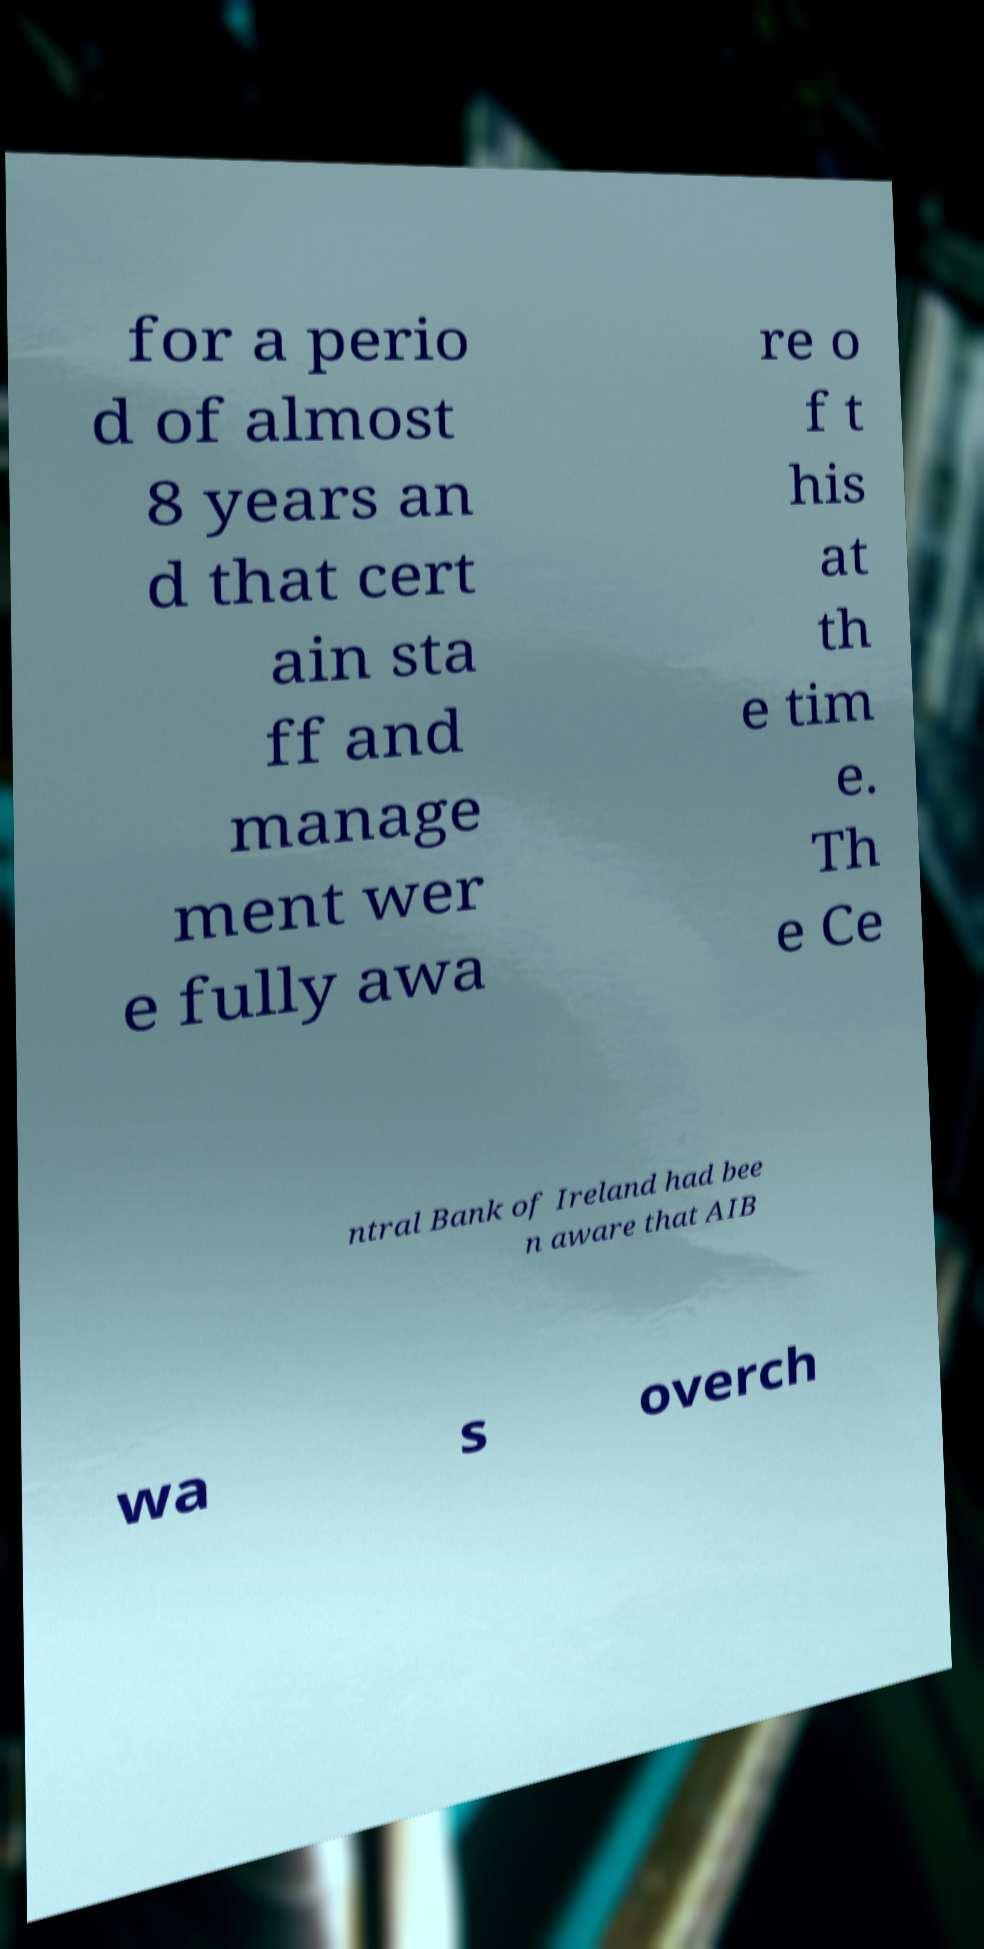Can you read and provide the text displayed in the image?This photo seems to have some interesting text. Can you extract and type it out for me? for a perio d of almost 8 years an d that cert ain sta ff and manage ment wer e fully awa re o f t his at th e tim e. Th e Ce ntral Bank of Ireland had bee n aware that AIB wa s overch 